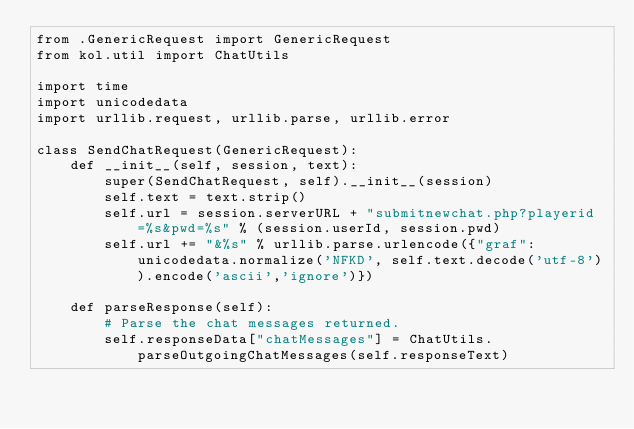Convert code to text. <code><loc_0><loc_0><loc_500><loc_500><_Python_>from .GenericRequest import GenericRequest
from kol.util import ChatUtils

import time
import unicodedata
import urllib.request, urllib.parse, urllib.error

class SendChatRequest(GenericRequest):
    def __init__(self, session, text):
        super(SendChatRequest, self).__init__(session)
        self.text = text.strip()
        self.url = session.serverURL + "submitnewchat.php?playerid=%s&pwd=%s" % (session.userId, session.pwd)
        self.url += "&%s" % urllib.parse.urlencode({"graf":unicodedata.normalize('NFKD', self.text.decode('utf-8')).encode('ascii','ignore')})

    def parseResponse(self):
        # Parse the chat messages returned.
        self.responseData["chatMessages"] = ChatUtils.parseOutgoingChatMessages(self.responseText)
</code> 